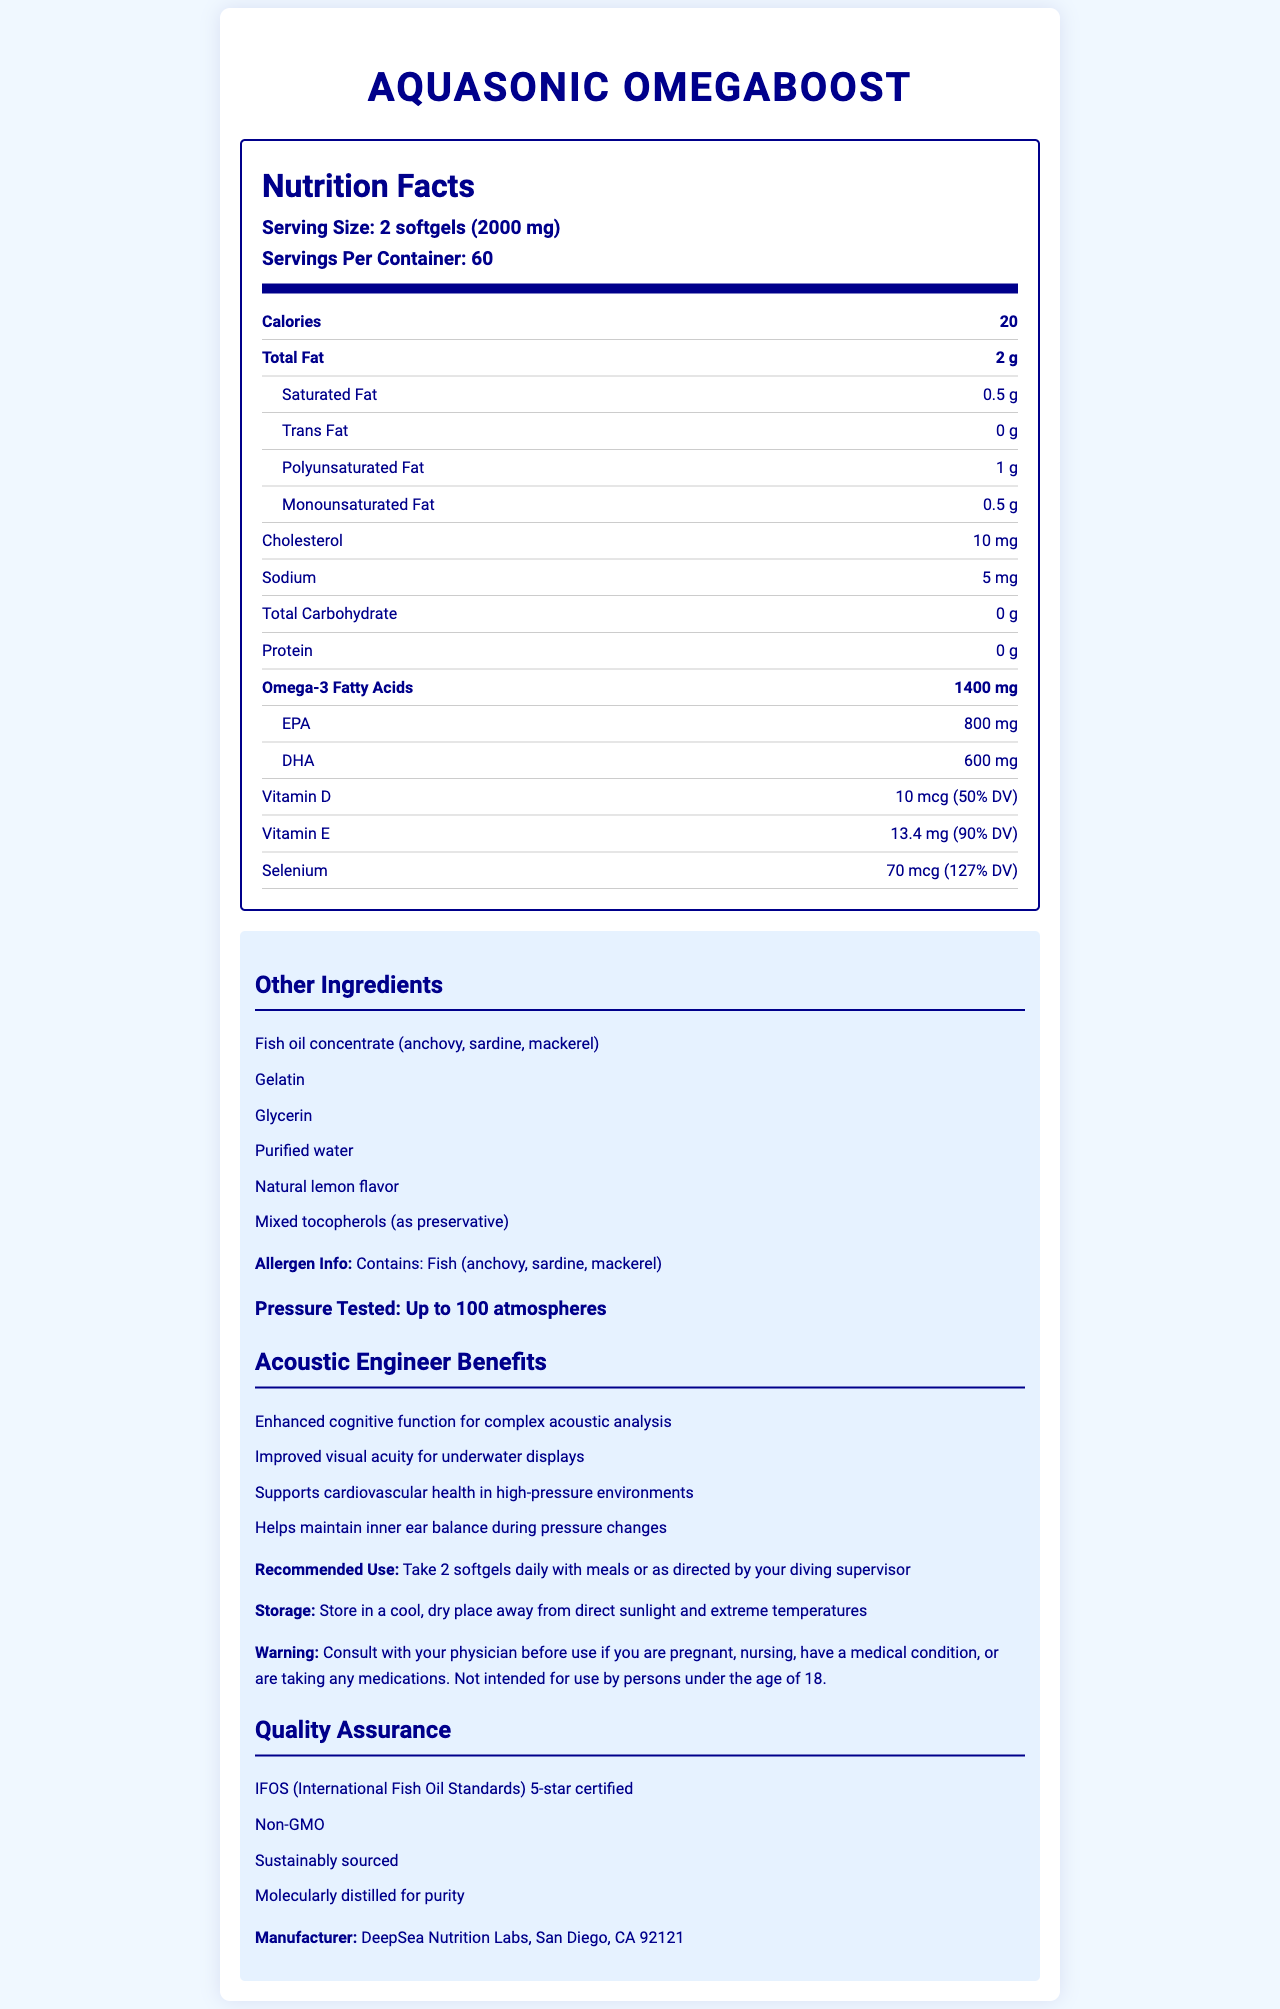what is the serving size? The serving size is listed at the top of the Nutrition Facts label under the "Nutrition Facts" heading in the section detailing the serving size and servings per container.
Answer: 2 softgels (2000 mg) what is the total amount of omega-3 fatty acids in a serving? The total amount of omega-3 fatty acids is specified in the nutrition facts section, under the bolded "Omega-3 Fatty Acids".
Answer: 1400 mg how many calories are in each serving? The calorie count per serving is prominently displayed under the "Calories" heading in the Nutrition Facts section.
Answer: 20 what are the primary ingredients in the fish oil concentrate? The primary ingredients are listed in the "Other Ingredients" section, noting "Fish oil concentrate (anchovy, sardine, mackerel)".
Answer: Anchovy, sardine, mackerel is there any protein in this product? The nutrition facts explicitly state that the protein content is "0 g".
Answer: No what benefits does this product offer to acoustic engineers? The benefits are listed under the "Acoustic Engineer Benefits" section in the additional information part of the document.
Answer: Enhanced cognitive function, Improved visual acuity, Supports cardiovascular health, Helps maintain inner ear balance what is the recommended use for this product? The recommended use is described in the part of the document titled "Recommended Use".
Answer: Take 2 softgels daily with meals or as directed by your diving supervisor what certifications does this product have? A. IFOS certified B. Non-GMO C. USDA Organic D. Sustainably sourced The product is labeled with "IFOS (International Fish Oil Standards) 5-star certified," "Non-GMO," and "Sustainably sourced" in the "Quality Assurance" section.
Answer: A, B, D how much selenium is in a serving? The selenium content is displayed in the nutrition facts section mentioning "Selenium" with the corresponding amount and daily value percentage.
Answer: 70 mcg (127% DV) which of the following contains the highest amount in this supplement? A. EPA B. DHA C. Saturated Fat According to the nutrition information, EPA (800 mg) has the highest value compared to DHA (600 mg) and Saturated Fat (0.5 g).
Answer: A. EPA does this product contain any allergens? The document specifies "Contains: Fish (anchovy, sardine, mackerel)" under the Allergen Info section.
Answer: Yes are there any trans fats in this product? The nutrition facts state that trans fat content is "0 g".
Answer: No what is the main idea of this document? The document is focused on describing the contents, benefits, usage, and quality assurances of the AquaSonic OmegaBoost, specifically tailored for acoustic engineers.
Answer: It provides detailed nutrition information, benefits, and usage instructions for AquaSonic OmegaBoost fish oil capsules, emphasizing its suitability for acoustic engineers in pressurized environments. where is the manufacturer located? The location of the manufacturer, DeepSea Nutrition Labs, is listed towards the end of the document.
Answer: San Diego, CA 92121 how is this product pressure tested? This information is found in the "Pressure Tested" section of the document, indicating the product's suitability for high-pressure environments.
Answer: Up to 100 atmospheres why is this product beneficial for cardiovascular health in high-pressure environments? The "Acoustic Engineer Benefits" lists cardiovascular support as one of the benefits, and the product's omega-3 content is beneficial for heart health in pressurized conditions.
Answer: It supports cardiovascular health through the omega-3 fatty acids which are beneficial for heart health, combined with a formulation that withstands high pressure does this product contain added sugars? The document does not provide any specific information about added sugars, only the total carbohydrate, which is "0 g".
Answer: Not enough information what are the product's storage instructions? The storage instructions are found in the additional information section under "Storage".
Answer: Store in a cool, dry place away from direct sunlight and extreme temperatures 